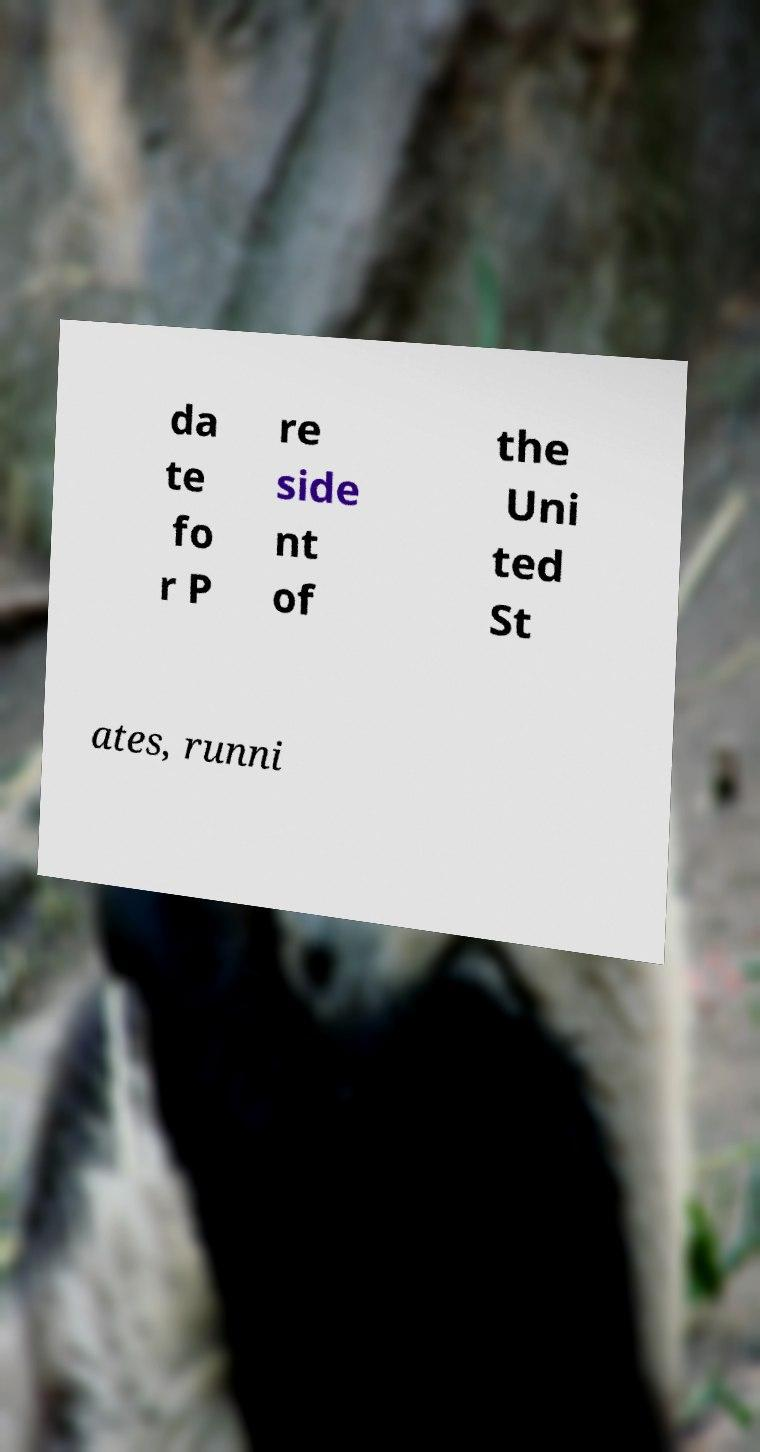For documentation purposes, I need the text within this image transcribed. Could you provide that? da te fo r P re side nt of the Uni ted St ates, runni 